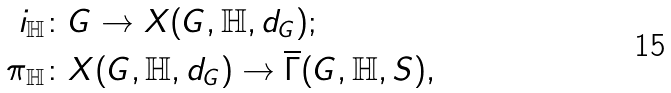Convert formula to latex. <formula><loc_0><loc_0><loc_500><loc_500>i _ { \mathbb { H } } & \colon G \to X ( G , { \mathbb { H } } , d _ { G } ) ; \\ \pi _ { \mathbb { H } } & \colon X ( G , { \mathbb { H } } , d _ { G } ) \to \overline { \Gamma } ( G , { \mathbb { H } } , S ) ,</formula> 